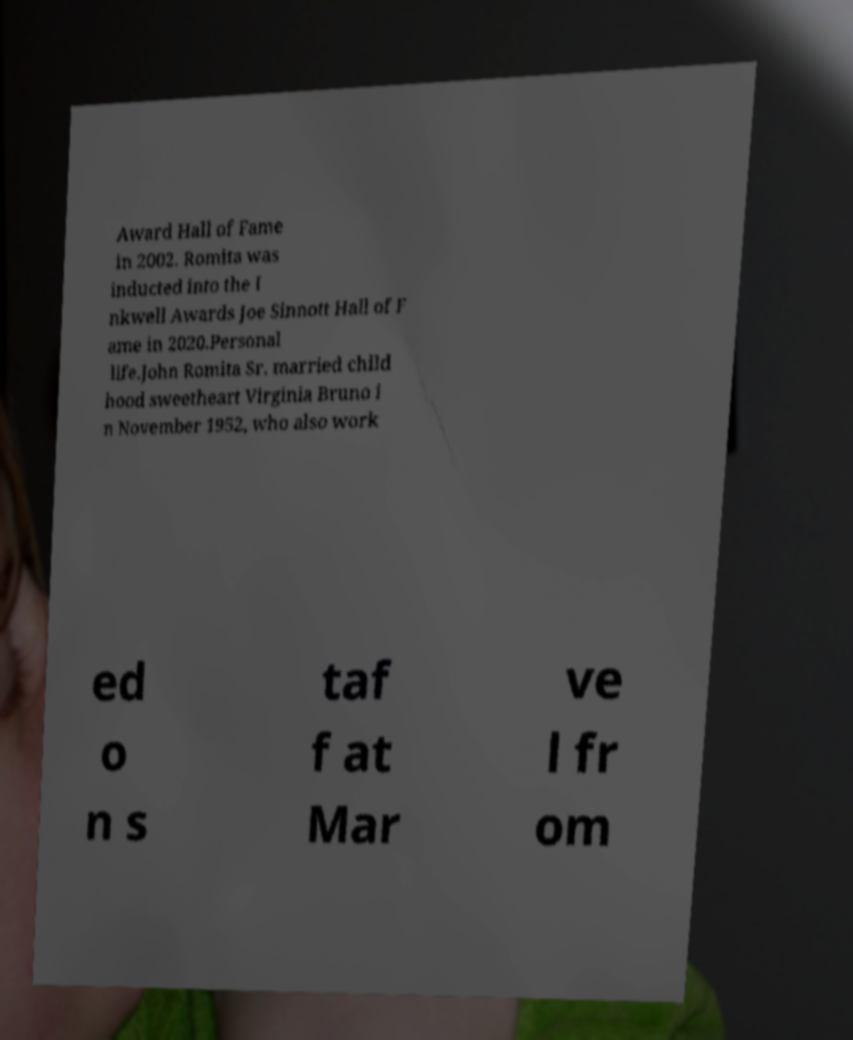Could you extract and type out the text from this image? Award Hall of Fame in 2002. Romita was inducted into the I nkwell Awards Joe Sinnott Hall of F ame in 2020.Personal life.John Romita Sr. married child hood sweetheart Virginia Bruno i n November 1952, who also work ed o n s taf f at Mar ve l fr om 